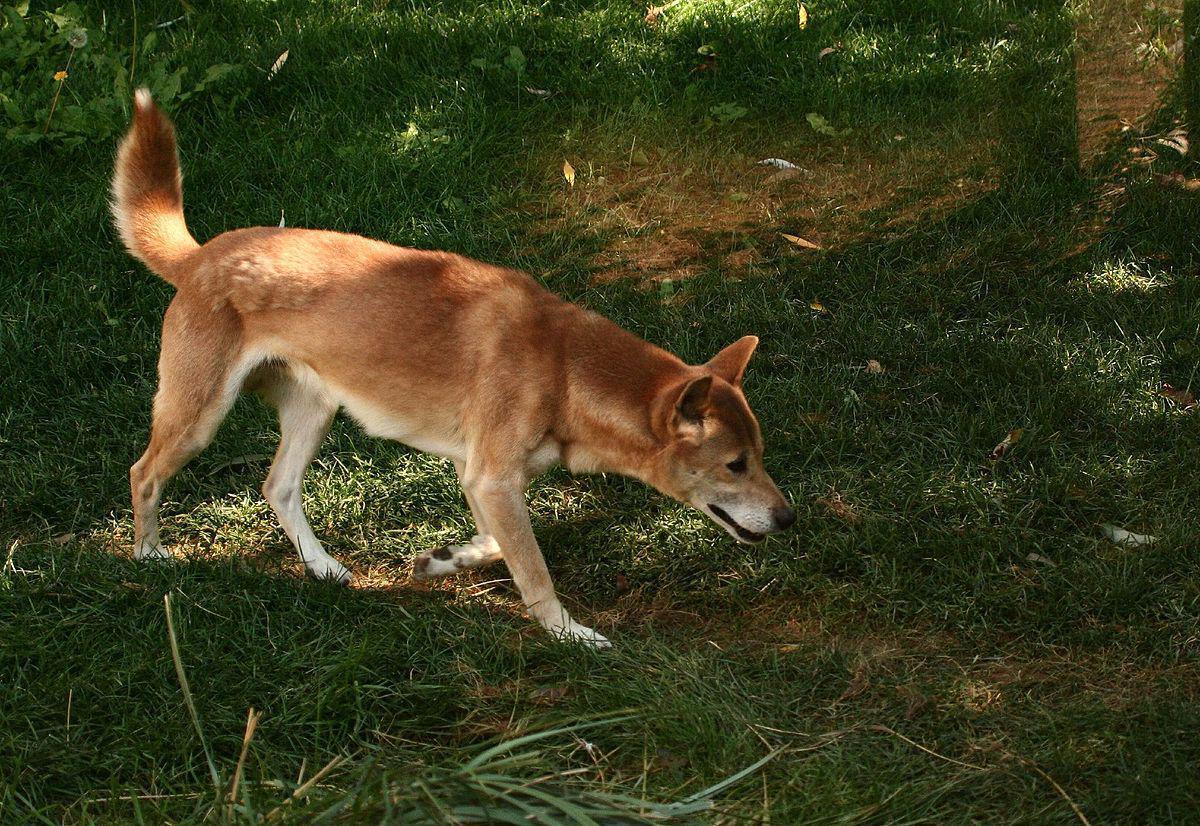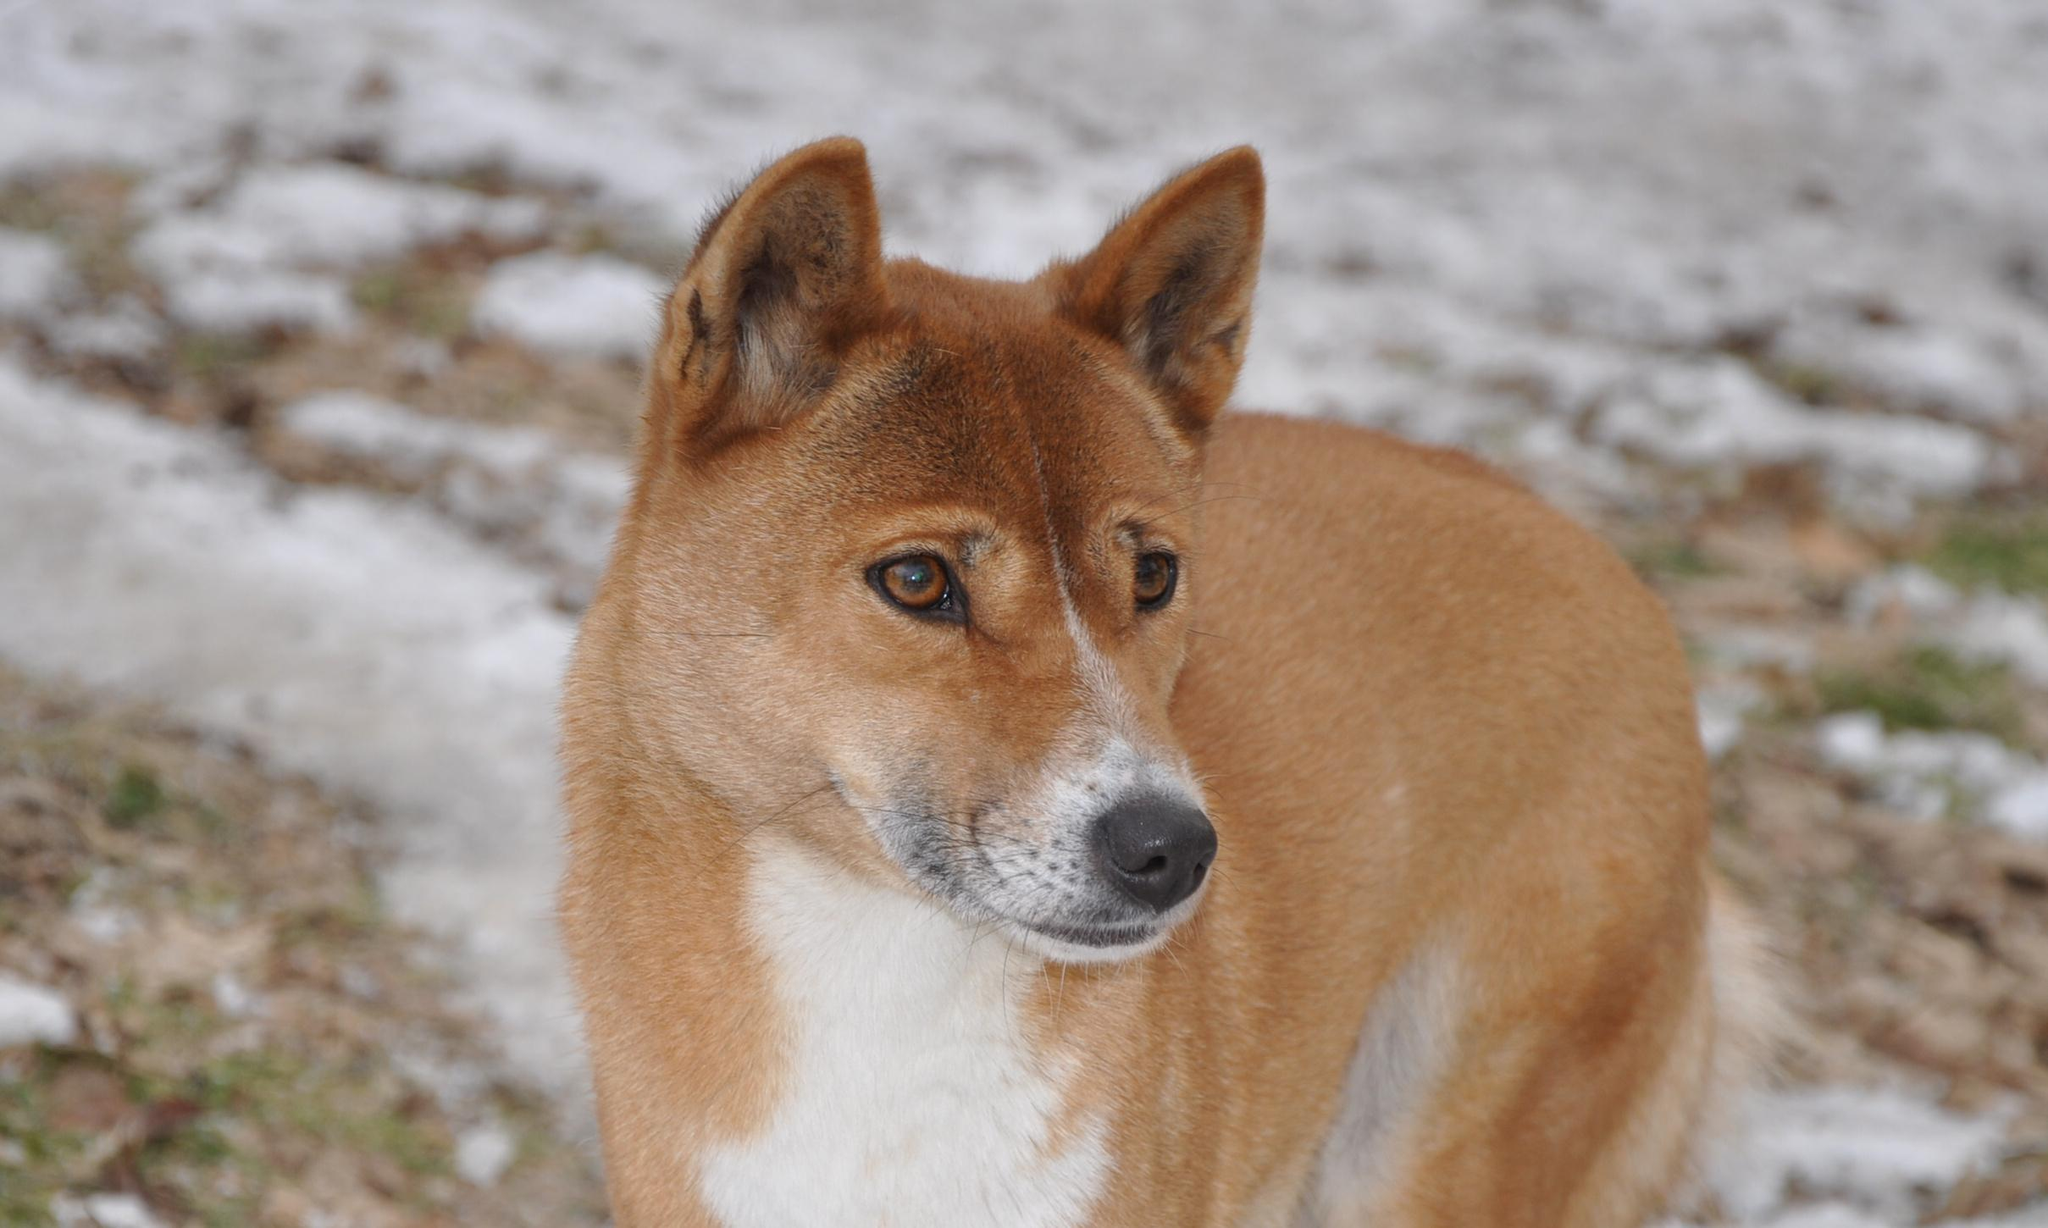The first image is the image on the left, the second image is the image on the right. Given the left and right images, does the statement "Right image shows a canine looking directly into the camera." hold true? Answer yes or no. No. The first image is the image on the left, the second image is the image on the right. For the images displayed, is the sentence "The animal in the image on the right is looking toward the camera" factually correct? Answer yes or no. No. 